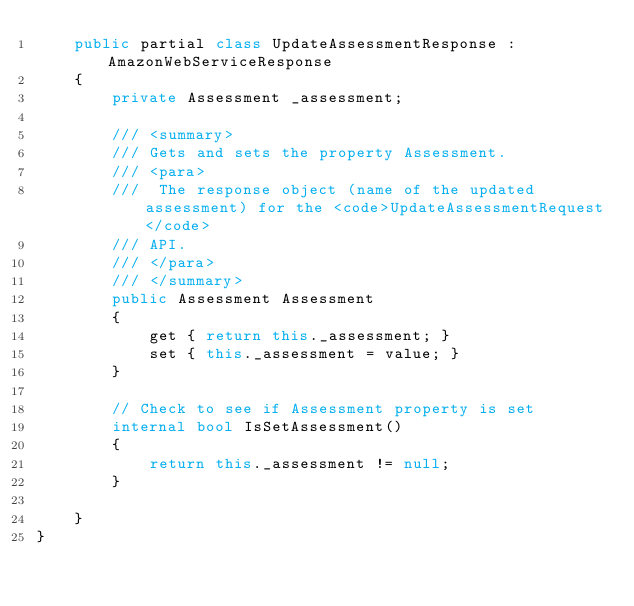<code> <loc_0><loc_0><loc_500><loc_500><_C#_>    public partial class UpdateAssessmentResponse : AmazonWebServiceResponse
    {
        private Assessment _assessment;

        /// <summary>
        /// Gets and sets the property Assessment. 
        /// <para>
        ///  The response object (name of the updated assessment) for the <code>UpdateAssessmentRequest</code>
        /// API. 
        /// </para>
        /// </summary>
        public Assessment Assessment
        {
            get { return this._assessment; }
            set { this._assessment = value; }
        }

        // Check to see if Assessment property is set
        internal bool IsSetAssessment()
        {
            return this._assessment != null;
        }

    }
}</code> 